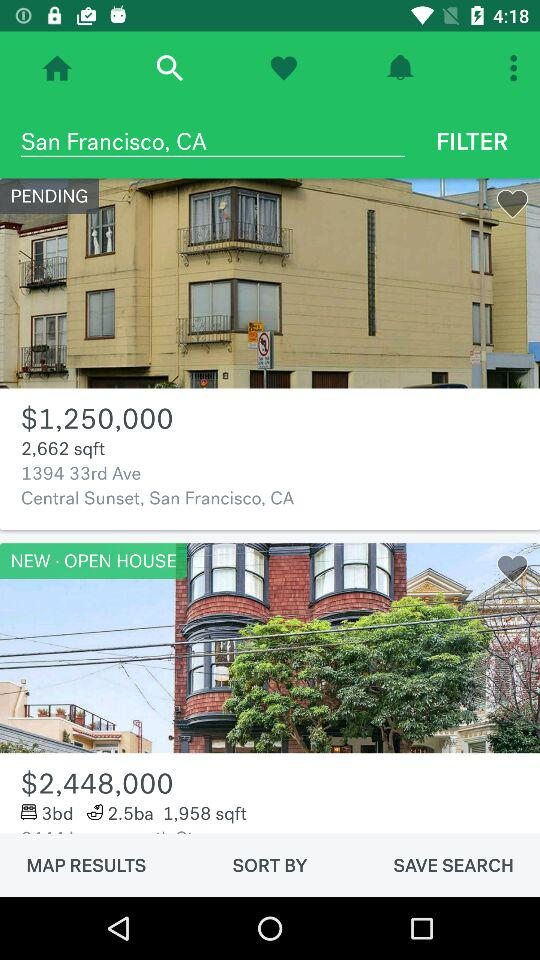What is the price of a 2,662 sqft house? The price of a 2,662 sqft house is $1,250,000. 